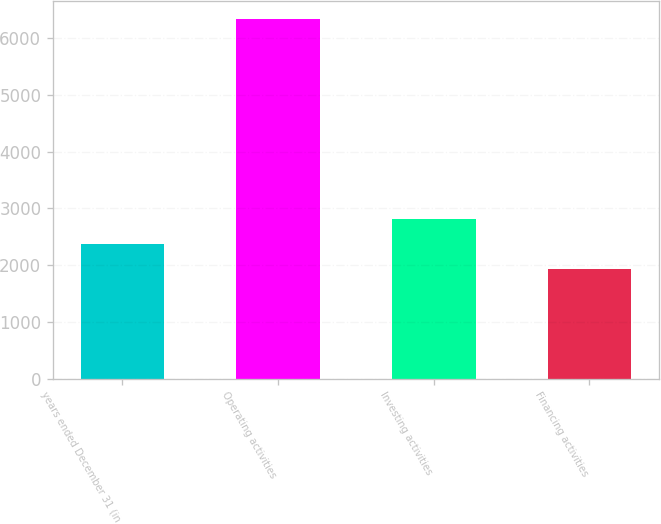<chart> <loc_0><loc_0><loc_500><loc_500><bar_chart><fcel>years ended December 31 (in<fcel>Operating activities<fcel>Investing activities<fcel>Financing activities<nl><fcel>2372.4<fcel>6345<fcel>2813.8<fcel>1931<nl></chart> 